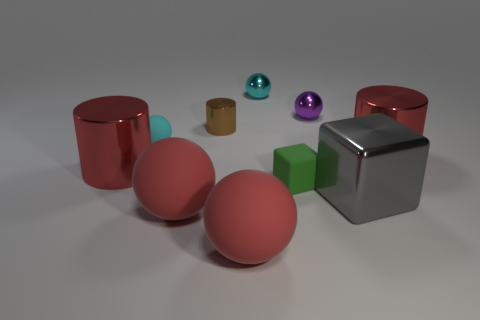Subtract 2 balls. How many balls are left? 3 Subtract all purple spheres. How many spheres are left? 4 Subtract all tiny purple balls. How many balls are left? 4 Subtract all brown balls. Subtract all purple cubes. How many balls are left? 5 Subtract all blocks. How many objects are left? 8 Add 4 cubes. How many cubes exist? 6 Subtract 0 red cubes. How many objects are left? 10 Subtract all small cyan metal things. Subtract all large spheres. How many objects are left? 7 Add 2 tiny green matte objects. How many tiny green matte objects are left? 3 